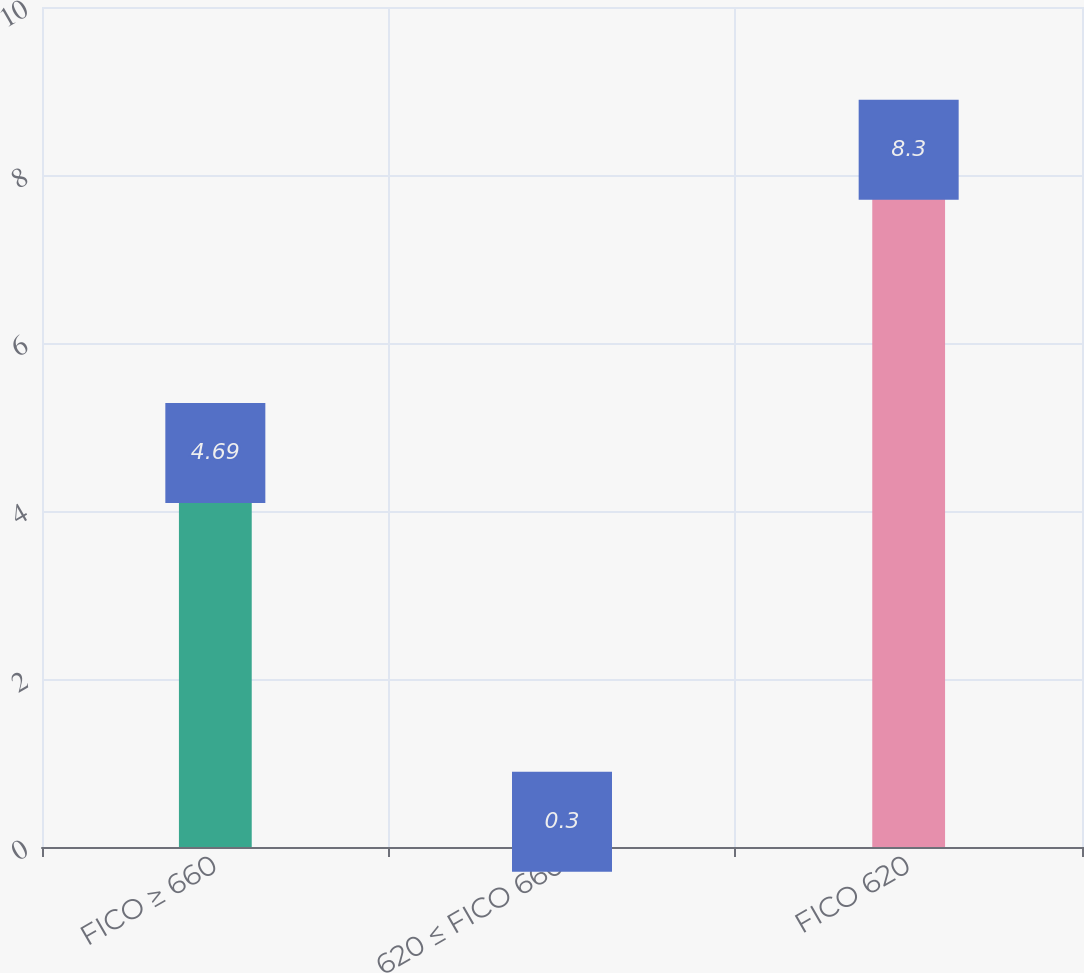Convert chart to OTSL. <chart><loc_0><loc_0><loc_500><loc_500><bar_chart><fcel>FICO ≥ 660<fcel>620 ≤ FICO 660<fcel>FICO 620<nl><fcel>4.69<fcel>0.3<fcel>8.3<nl></chart> 